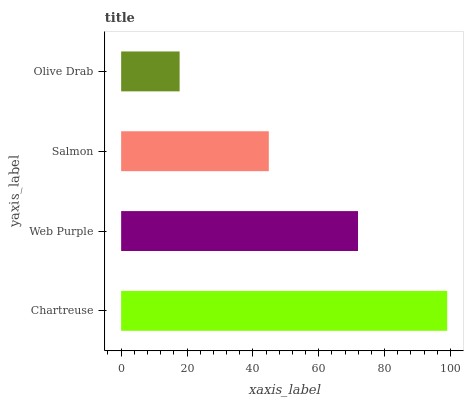Is Olive Drab the minimum?
Answer yes or no. Yes. Is Chartreuse the maximum?
Answer yes or no. Yes. Is Web Purple the minimum?
Answer yes or no. No. Is Web Purple the maximum?
Answer yes or no. No. Is Chartreuse greater than Web Purple?
Answer yes or no. Yes. Is Web Purple less than Chartreuse?
Answer yes or no. Yes. Is Web Purple greater than Chartreuse?
Answer yes or no. No. Is Chartreuse less than Web Purple?
Answer yes or no. No. Is Web Purple the high median?
Answer yes or no. Yes. Is Salmon the low median?
Answer yes or no. Yes. Is Olive Drab the high median?
Answer yes or no. No. Is Chartreuse the low median?
Answer yes or no. No. 